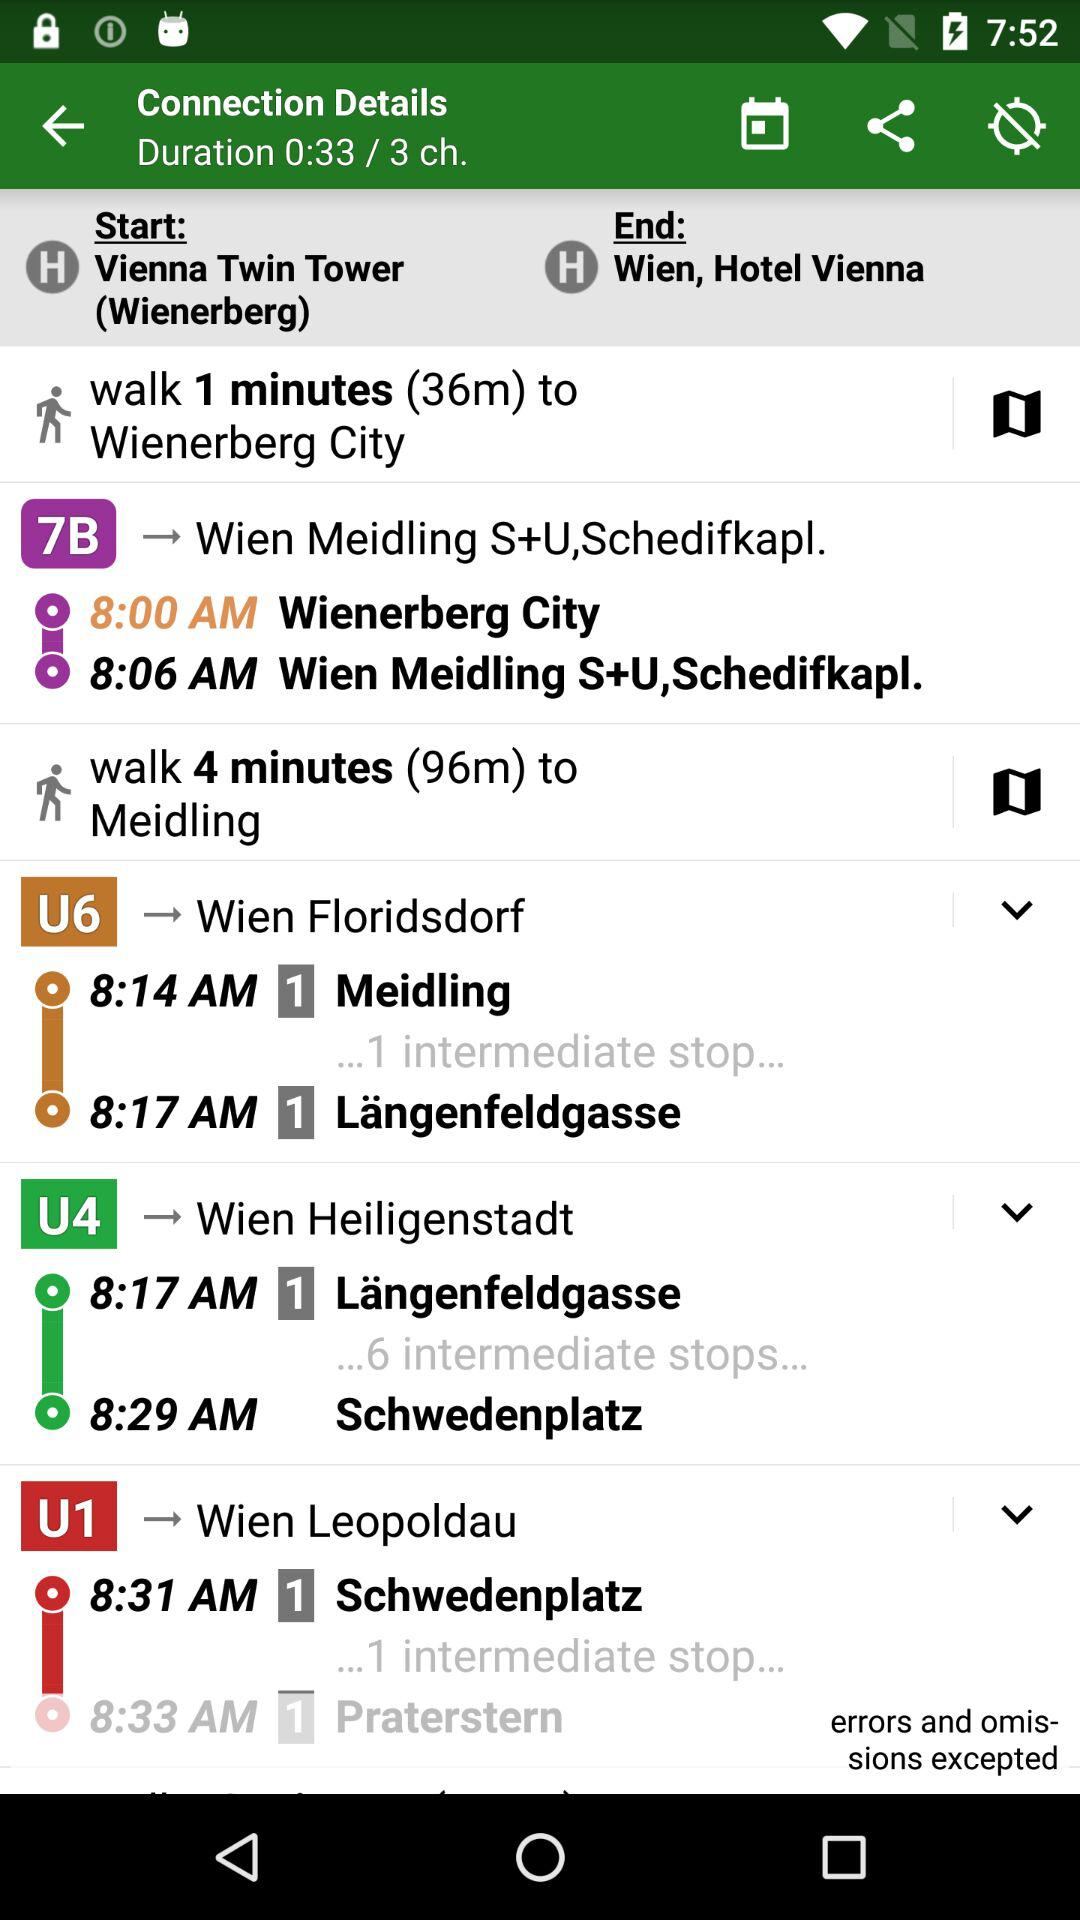What is the duration? The duration is 33 seconds. 